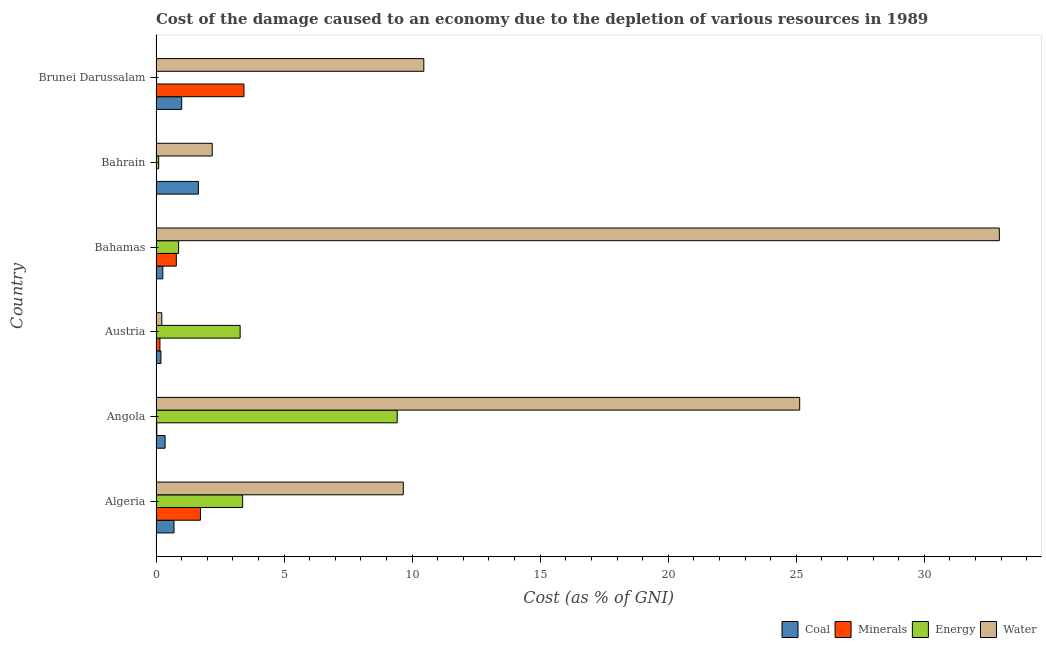How many different coloured bars are there?
Make the answer very short. 4. Are the number of bars on each tick of the Y-axis equal?
Offer a very short reply. Yes. How many bars are there on the 6th tick from the top?
Your response must be concise. 4. How many bars are there on the 6th tick from the bottom?
Your answer should be compact. 4. What is the label of the 2nd group of bars from the top?
Your answer should be compact. Bahrain. In how many cases, is the number of bars for a given country not equal to the number of legend labels?
Offer a terse response. 0. What is the cost of damage due to depletion of energy in Austria?
Provide a short and direct response. 3.28. Across all countries, what is the maximum cost of damage due to depletion of energy?
Make the answer very short. 9.42. Across all countries, what is the minimum cost of damage due to depletion of energy?
Your response must be concise. 0.02. In which country was the cost of damage due to depletion of minerals maximum?
Offer a very short reply. Brunei Darussalam. In which country was the cost of damage due to depletion of minerals minimum?
Your answer should be very brief. Bahrain. What is the total cost of damage due to depletion of water in the graph?
Provide a short and direct response. 80.59. What is the difference between the cost of damage due to depletion of water in Bahamas and that in Bahrain?
Make the answer very short. 30.73. What is the difference between the cost of damage due to depletion of minerals in Austria and the cost of damage due to depletion of energy in Bahrain?
Your answer should be compact. 0.05. What is the average cost of damage due to depletion of minerals per country?
Your response must be concise. 1.02. What is the ratio of the cost of damage due to depletion of coal in Angola to that in Austria?
Provide a short and direct response. 1.85. What is the difference between the highest and the second highest cost of damage due to depletion of coal?
Offer a terse response. 0.65. What is the difference between the highest and the lowest cost of damage due to depletion of energy?
Your answer should be very brief. 9.4. In how many countries, is the cost of damage due to depletion of minerals greater than the average cost of damage due to depletion of minerals taken over all countries?
Your answer should be very brief. 2. Is it the case that in every country, the sum of the cost of damage due to depletion of water and cost of damage due to depletion of coal is greater than the sum of cost of damage due to depletion of minerals and cost of damage due to depletion of energy?
Your answer should be very brief. No. What does the 1st bar from the top in Bahamas represents?
Provide a short and direct response. Water. What does the 1st bar from the bottom in Algeria represents?
Your answer should be very brief. Coal. Are all the bars in the graph horizontal?
Keep it short and to the point. Yes. How many countries are there in the graph?
Offer a terse response. 6. Are the values on the major ticks of X-axis written in scientific E-notation?
Make the answer very short. No. Does the graph contain any zero values?
Offer a terse response. No. Where does the legend appear in the graph?
Offer a terse response. Bottom right. What is the title of the graph?
Offer a very short reply. Cost of the damage caused to an economy due to the depletion of various resources in 1989 . What is the label or title of the X-axis?
Provide a succinct answer. Cost (as % of GNI). What is the label or title of the Y-axis?
Make the answer very short. Country. What is the Cost (as % of GNI) in Coal in Algeria?
Ensure brevity in your answer.  0.7. What is the Cost (as % of GNI) in Minerals in Algeria?
Make the answer very short. 1.73. What is the Cost (as % of GNI) in Energy in Algeria?
Give a very brief answer. 3.38. What is the Cost (as % of GNI) of Water in Algeria?
Provide a succinct answer. 9.66. What is the Cost (as % of GNI) in Coal in Angola?
Provide a succinct answer. 0.35. What is the Cost (as % of GNI) in Minerals in Angola?
Provide a short and direct response. 0.03. What is the Cost (as % of GNI) of Energy in Angola?
Keep it short and to the point. 9.42. What is the Cost (as % of GNI) of Water in Angola?
Offer a very short reply. 25.13. What is the Cost (as % of GNI) in Coal in Austria?
Offer a terse response. 0.19. What is the Cost (as % of GNI) in Minerals in Austria?
Ensure brevity in your answer.  0.15. What is the Cost (as % of GNI) in Energy in Austria?
Your response must be concise. 3.28. What is the Cost (as % of GNI) in Water in Austria?
Offer a very short reply. 0.23. What is the Cost (as % of GNI) in Coal in Bahamas?
Your response must be concise. 0.27. What is the Cost (as % of GNI) in Minerals in Bahamas?
Your response must be concise. 0.79. What is the Cost (as % of GNI) in Energy in Bahamas?
Your answer should be very brief. 0.88. What is the Cost (as % of GNI) in Water in Bahamas?
Provide a succinct answer. 32.93. What is the Cost (as % of GNI) of Coal in Bahrain?
Your answer should be compact. 1.66. What is the Cost (as % of GNI) in Minerals in Bahrain?
Provide a succinct answer. 0.01. What is the Cost (as % of GNI) in Energy in Bahrain?
Give a very brief answer. 0.1. What is the Cost (as % of GNI) in Water in Bahrain?
Keep it short and to the point. 2.19. What is the Cost (as % of GNI) in Coal in Brunei Darussalam?
Your response must be concise. 1. What is the Cost (as % of GNI) in Minerals in Brunei Darussalam?
Ensure brevity in your answer.  3.43. What is the Cost (as % of GNI) in Energy in Brunei Darussalam?
Give a very brief answer. 0.02. What is the Cost (as % of GNI) of Water in Brunei Darussalam?
Keep it short and to the point. 10.46. Across all countries, what is the maximum Cost (as % of GNI) in Coal?
Offer a terse response. 1.66. Across all countries, what is the maximum Cost (as % of GNI) in Minerals?
Offer a terse response. 3.43. Across all countries, what is the maximum Cost (as % of GNI) in Energy?
Provide a short and direct response. 9.42. Across all countries, what is the maximum Cost (as % of GNI) of Water?
Your answer should be very brief. 32.93. Across all countries, what is the minimum Cost (as % of GNI) in Coal?
Your answer should be very brief. 0.19. Across all countries, what is the minimum Cost (as % of GNI) in Minerals?
Provide a short and direct response. 0.01. Across all countries, what is the minimum Cost (as % of GNI) of Energy?
Keep it short and to the point. 0.02. Across all countries, what is the minimum Cost (as % of GNI) of Water?
Make the answer very short. 0.23. What is the total Cost (as % of GNI) in Coal in the graph?
Ensure brevity in your answer.  4.17. What is the total Cost (as % of GNI) in Minerals in the graph?
Make the answer very short. 6.15. What is the total Cost (as % of GNI) of Energy in the graph?
Your answer should be compact. 17.09. What is the total Cost (as % of GNI) in Water in the graph?
Offer a terse response. 80.59. What is the difference between the Cost (as % of GNI) of Coal in Algeria and that in Angola?
Provide a succinct answer. 0.35. What is the difference between the Cost (as % of GNI) of Minerals in Algeria and that in Angola?
Offer a terse response. 1.7. What is the difference between the Cost (as % of GNI) in Energy in Algeria and that in Angola?
Provide a short and direct response. -6.04. What is the difference between the Cost (as % of GNI) of Water in Algeria and that in Angola?
Offer a terse response. -15.48. What is the difference between the Cost (as % of GNI) of Coal in Algeria and that in Austria?
Your response must be concise. 0.51. What is the difference between the Cost (as % of GNI) in Minerals in Algeria and that in Austria?
Your answer should be compact. 1.58. What is the difference between the Cost (as % of GNI) of Energy in Algeria and that in Austria?
Your answer should be very brief. 0.1. What is the difference between the Cost (as % of GNI) of Water in Algeria and that in Austria?
Ensure brevity in your answer.  9.43. What is the difference between the Cost (as % of GNI) of Coal in Algeria and that in Bahamas?
Your answer should be compact. 0.44. What is the difference between the Cost (as % of GNI) in Minerals in Algeria and that in Bahamas?
Give a very brief answer. 0.94. What is the difference between the Cost (as % of GNI) of Energy in Algeria and that in Bahamas?
Keep it short and to the point. 2.5. What is the difference between the Cost (as % of GNI) of Water in Algeria and that in Bahamas?
Give a very brief answer. -23.27. What is the difference between the Cost (as % of GNI) of Coal in Algeria and that in Bahrain?
Provide a succinct answer. -0.95. What is the difference between the Cost (as % of GNI) of Minerals in Algeria and that in Bahrain?
Offer a terse response. 1.73. What is the difference between the Cost (as % of GNI) in Energy in Algeria and that in Bahrain?
Offer a very short reply. 3.28. What is the difference between the Cost (as % of GNI) in Water in Algeria and that in Bahrain?
Ensure brevity in your answer.  7.46. What is the difference between the Cost (as % of GNI) in Coal in Algeria and that in Brunei Darussalam?
Your answer should be compact. -0.3. What is the difference between the Cost (as % of GNI) in Minerals in Algeria and that in Brunei Darussalam?
Ensure brevity in your answer.  -1.7. What is the difference between the Cost (as % of GNI) in Energy in Algeria and that in Brunei Darussalam?
Give a very brief answer. 3.36. What is the difference between the Cost (as % of GNI) of Water in Algeria and that in Brunei Darussalam?
Keep it short and to the point. -0.8. What is the difference between the Cost (as % of GNI) in Coal in Angola and that in Austria?
Offer a terse response. 0.16. What is the difference between the Cost (as % of GNI) in Minerals in Angola and that in Austria?
Provide a succinct answer. -0.12. What is the difference between the Cost (as % of GNI) in Energy in Angola and that in Austria?
Your response must be concise. 6.13. What is the difference between the Cost (as % of GNI) in Water in Angola and that in Austria?
Offer a terse response. 24.91. What is the difference between the Cost (as % of GNI) of Coal in Angola and that in Bahamas?
Provide a succinct answer. 0.09. What is the difference between the Cost (as % of GNI) of Minerals in Angola and that in Bahamas?
Your answer should be compact. -0.76. What is the difference between the Cost (as % of GNI) in Energy in Angola and that in Bahamas?
Provide a short and direct response. 8.54. What is the difference between the Cost (as % of GNI) in Water in Angola and that in Bahamas?
Provide a short and direct response. -7.8. What is the difference between the Cost (as % of GNI) in Coal in Angola and that in Bahrain?
Your answer should be compact. -1.3. What is the difference between the Cost (as % of GNI) of Minerals in Angola and that in Bahrain?
Your answer should be very brief. 0.02. What is the difference between the Cost (as % of GNI) of Energy in Angola and that in Bahrain?
Ensure brevity in your answer.  9.31. What is the difference between the Cost (as % of GNI) of Water in Angola and that in Bahrain?
Offer a terse response. 22.94. What is the difference between the Cost (as % of GNI) in Coal in Angola and that in Brunei Darussalam?
Make the answer very short. -0.65. What is the difference between the Cost (as % of GNI) in Minerals in Angola and that in Brunei Darussalam?
Offer a terse response. -3.4. What is the difference between the Cost (as % of GNI) in Energy in Angola and that in Brunei Darussalam?
Ensure brevity in your answer.  9.4. What is the difference between the Cost (as % of GNI) of Water in Angola and that in Brunei Darussalam?
Your answer should be compact. 14.68. What is the difference between the Cost (as % of GNI) in Coal in Austria and that in Bahamas?
Offer a terse response. -0.07. What is the difference between the Cost (as % of GNI) in Minerals in Austria and that in Bahamas?
Your answer should be compact. -0.64. What is the difference between the Cost (as % of GNI) in Energy in Austria and that in Bahamas?
Your answer should be very brief. 2.4. What is the difference between the Cost (as % of GNI) in Water in Austria and that in Bahamas?
Provide a succinct answer. -32.7. What is the difference between the Cost (as % of GNI) of Coal in Austria and that in Bahrain?
Provide a short and direct response. -1.46. What is the difference between the Cost (as % of GNI) in Minerals in Austria and that in Bahrain?
Ensure brevity in your answer.  0.15. What is the difference between the Cost (as % of GNI) in Energy in Austria and that in Bahrain?
Offer a terse response. 3.18. What is the difference between the Cost (as % of GNI) of Water in Austria and that in Bahrain?
Give a very brief answer. -1.97. What is the difference between the Cost (as % of GNI) in Coal in Austria and that in Brunei Darussalam?
Provide a short and direct response. -0.81. What is the difference between the Cost (as % of GNI) in Minerals in Austria and that in Brunei Darussalam?
Ensure brevity in your answer.  -3.28. What is the difference between the Cost (as % of GNI) of Energy in Austria and that in Brunei Darussalam?
Your answer should be very brief. 3.26. What is the difference between the Cost (as % of GNI) of Water in Austria and that in Brunei Darussalam?
Provide a short and direct response. -10.23. What is the difference between the Cost (as % of GNI) in Coal in Bahamas and that in Bahrain?
Make the answer very short. -1.39. What is the difference between the Cost (as % of GNI) in Minerals in Bahamas and that in Bahrain?
Provide a succinct answer. 0.79. What is the difference between the Cost (as % of GNI) of Energy in Bahamas and that in Bahrain?
Ensure brevity in your answer.  0.78. What is the difference between the Cost (as % of GNI) of Water in Bahamas and that in Bahrain?
Give a very brief answer. 30.73. What is the difference between the Cost (as % of GNI) in Coal in Bahamas and that in Brunei Darussalam?
Provide a short and direct response. -0.74. What is the difference between the Cost (as % of GNI) of Minerals in Bahamas and that in Brunei Darussalam?
Give a very brief answer. -2.64. What is the difference between the Cost (as % of GNI) of Energy in Bahamas and that in Brunei Darussalam?
Your answer should be very brief. 0.86. What is the difference between the Cost (as % of GNI) in Water in Bahamas and that in Brunei Darussalam?
Offer a terse response. 22.47. What is the difference between the Cost (as % of GNI) in Coal in Bahrain and that in Brunei Darussalam?
Make the answer very short. 0.65. What is the difference between the Cost (as % of GNI) in Minerals in Bahrain and that in Brunei Darussalam?
Offer a very short reply. -3.43. What is the difference between the Cost (as % of GNI) in Energy in Bahrain and that in Brunei Darussalam?
Give a very brief answer. 0.08. What is the difference between the Cost (as % of GNI) of Water in Bahrain and that in Brunei Darussalam?
Make the answer very short. -8.26. What is the difference between the Cost (as % of GNI) of Coal in Algeria and the Cost (as % of GNI) of Minerals in Angola?
Provide a short and direct response. 0.67. What is the difference between the Cost (as % of GNI) in Coal in Algeria and the Cost (as % of GNI) in Energy in Angola?
Provide a short and direct response. -8.72. What is the difference between the Cost (as % of GNI) in Coal in Algeria and the Cost (as % of GNI) in Water in Angola?
Keep it short and to the point. -24.43. What is the difference between the Cost (as % of GNI) in Minerals in Algeria and the Cost (as % of GNI) in Energy in Angola?
Offer a very short reply. -7.68. What is the difference between the Cost (as % of GNI) in Minerals in Algeria and the Cost (as % of GNI) in Water in Angola?
Your answer should be very brief. -23.4. What is the difference between the Cost (as % of GNI) of Energy in Algeria and the Cost (as % of GNI) of Water in Angola?
Your answer should be compact. -21.75. What is the difference between the Cost (as % of GNI) of Coal in Algeria and the Cost (as % of GNI) of Minerals in Austria?
Provide a short and direct response. 0.55. What is the difference between the Cost (as % of GNI) of Coal in Algeria and the Cost (as % of GNI) of Energy in Austria?
Your answer should be very brief. -2.58. What is the difference between the Cost (as % of GNI) in Coal in Algeria and the Cost (as % of GNI) in Water in Austria?
Your answer should be very brief. 0.48. What is the difference between the Cost (as % of GNI) of Minerals in Algeria and the Cost (as % of GNI) of Energy in Austria?
Keep it short and to the point. -1.55. What is the difference between the Cost (as % of GNI) in Minerals in Algeria and the Cost (as % of GNI) in Water in Austria?
Offer a terse response. 1.51. What is the difference between the Cost (as % of GNI) of Energy in Algeria and the Cost (as % of GNI) of Water in Austria?
Keep it short and to the point. 3.16. What is the difference between the Cost (as % of GNI) in Coal in Algeria and the Cost (as % of GNI) in Minerals in Bahamas?
Provide a succinct answer. -0.09. What is the difference between the Cost (as % of GNI) in Coal in Algeria and the Cost (as % of GNI) in Energy in Bahamas?
Make the answer very short. -0.18. What is the difference between the Cost (as % of GNI) of Coal in Algeria and the Cost (as % of GNI) of Water in Bahamas?
Offer a very short reply. -32.23. What is the difference between the Cost (as % of GNI) of Minerals in Algeria and the Cost (as % of GNI) of Energy in Bahamas?
Your answer should be very brief. 0.85. What is the difference between the Cost (as % of GNI) in Minerals in Algeria and the Cost (as % of GNI) in Water in Bahamas?
Your answer should be compact. -31.19. What is the difference between the Cost (as % of GNI) of Energy in Algeria and the Cost (as % of GNI) of Water in Bahamas?
Offer a terse response. -29.55. What is the difference between the Cost (as % of GNI) of Coal in Algeria and the Cost (as % of GNI) of Minerals in Bahrain?
Provide a short and direct response. 0.69. What is the difference between the Cost (as % of GNI) of Coal in Algeria and the Cost (as % of GNI) of Energy in Bahrain?
Provide a succinct answer. 0.6. What is the difference between the Cost (as % of GNI) of Coal in Algeria and the Cost (as % of GNI) of Water in Bahrain?
Give a very brief answer. -1.49. What is the difference between the Cost (as % of GNI) in Minerals in Algeria and the Cost (as % of GNI) in Energy in Bahrain?
Your answer should be very brief. 1.63. What is the difference between the Cost (as % of GNI) in Minerals in Algeria and the Cost (as % of GNI) in Water in Bahrain?
Provide a short and direct response. -0.46. What is the difference between the Cost (as % of GNI) of Energy in Algeria and the Cost (as % of GNI) of Water in Bahrain?
Keep it short and to the point. 1.19. What is the difference between the Cost (as % of GNI) in Coal in Algeria and the Cost (as % of GNI) in Minerals in Brunei Darussalam?
Give a very brief answer. -2.73. What is the difference between the Cost (as % of GNI) in Coal in Algeria and the Cost (as % of GNI) in Energy in Brunei Darussalam?
Provide a short and direct response. 0.68. What is the difference between the Cost (as % of GNI) in Coal in Algeria and the Cost (as % of GNI) in Water in Brunei Darussalam?
Keep it short and to the point. -9.75. What is the difference between the Cost (as % of GNI) in Minerals in Algeria and the Cost (as % of GNI) in Energy in Brunei Darussalam?
Make the answer very short. 1.71. What is the difference between the Cost (as % of GNI) of Minerals in Algeria and the Cost (as % of GNI) of Water in Brunei Darussalam?
Provide a short and direct response. -8.72. What is the difference between the Cost (as % of GNI) in Energy in Algeria and the Cost (as % of GNI) in Water in Brunei Darussalam?
Ensure brevity in your answer.  -7.07. What is the difference between the Cost (as % of GNI) in Coal in Angola and the Cost (as % of GNI) in Minerals in Austria?
Make the answer very short. 0.2. What is the difference between the Cost (as % of GNI) of Coal in Angola and the Cost (as % of GNI) of Energy in Austria?
Offer a very short reply. -2.93. What is the difference between the Cost (as % of GNI) of Coal in Angola and the Cost (as % of GNI) of Water in Austria?
Your answer should be compact. 0.13. What is the difference between the Cost (as % of GNI) in Minerals in Angola and the Cost (as % of GNI) in Energy in Austria?
Ensure brevity in your answer.  -3.25. What is the difference between the Cost (as % of GNI) of Minerals in Angola and the Cost (as % of GNI) of Water in Austria?
Your response must be concise. -0.2. What is the difference between the Cost (as % of GNI) in Energy in Angola and the Cost (as % of GNI) in Water in Austria?
Keep it short and to the point. 9.19. What is the difference between the Cost (as % of GNI) in Coal in Angola and the Cost (as % of GNI) in Minerals in Bahamas?
Make the answer very short. -0.44. What is the difference between the Cost (as % of GNI) of Coal in Angola and the Cost (as % of GNI) of Energy in Bahamas?
Offer a very short reply. -0.53. What is the difference between the Cost (as % of GNI) of Coal in Angola and the Cost (as % of GNI) of Water in Bahamas?
Your response must be concise. -32.57. What is the difference between the Cost (as % of GNI) of Minerals in Angola and the Cost (as % of GNI) of Energy in Bahamas?
Provide a short and direct response. -0.85. What is the difference between the Cost (as % of GNI) in Minerals in Angola and the Cost (as % of GNI) in Water in Bahamas?
Your answer should be compact. -32.9. What is the difference between the Cost (as % of GNI) of Energy in Angola and the Cost (as % of GNI) of Water in Bahamas?
Provide a succinct answer. -23.51. What is the difference between the Cost (as % of GNI) in Coal in Angola and the Cost (as % of GNI) in Minerals in Bahrain?
Offer a terse response. 0.35. What is the difference between the Cost (as % of GNI) in Coal in Angola and the Cost (as % of GNI) in Energy in Bahrain?
Provide a short and direct response. 0.25. What is the difference between the Cost (as % of GNI) in Coal in Angola and the Cost (as % of GNI) in Water in Bahrain?
Make the answer very short. -1.84. What is the difference between the Cost (as % of GNI) of Minerals in Angola and the Cost (as % of GNI) of Energy in Bahrain?
Provide a succinct answer. -0.07. What is the difference between the Cost (as % of GNI) of Minerals in Angola and the Cost (as % of GNI) of Water in Bahrain?
Give a very brief answer. -2.16. What is the difference between the Cost (as % of GNI) of Energy in Angola and the Cost (as % of GNI) of Water in Bahrain?
Keep it short and to the point. 7.22. What is the difference between the Cost (as % of GNI) in Coal in Angola and the Cost (as % of GNI) in Minerals in Brunei Darussalam?
Provide a succinct answer. -3.08. What is the difference between the Cost (as % of GNI) in Coal in Angola and the Cost (as % of GNI) in Energy in Brunei Darussalam?
Offer a terse response. 0.33. What is the difference between the Cost (as % of GNI) of Coal in Angola and the Cost (as % of GNI) of Water in Brunei Darussalam?
Your answer should be compact. -10.1. What is the difference between the Cost (as % of GNI) of Minerals in Angola and the Cost (as % of GNI) of Energy in Brunei Darussalam?
Make the answer very short. 0.01. What is the difference between the Cost (as % of GNI) of Minerals in Angola and the Cost (as % of GNI) of Water in Brunei Darussalam?
Your answer should be very brief. -10.43. What is the difference between the Cost (as % of GNI) of Energy in Angola and the Cost (as % of GNI) of Water in Brunei Darussalam?
Your answer should be compact. -1.04. What is the difference between the Cost (as % of GNI) of Coal in Austria and the Cost (as % of GNI) of Minerals in Bahamas?
Your response must be concise. -0.6. What is the difference between the Cost (as % of GNI) of Coal in Austria and the Cost (as % of GNI) of Energy in Bahamas?
Offer a very short reply. -0.69. What is the difference between the Cost (as % of GNI) in Coal in Austria and the Cost (as % of GNI) in Water in Bahamas?
Provide a succinct answer. -32.74. What is the difference between the Cost (as % of GNI) of Minerals in Austria and the Cost (as % of GNI) of Energy in Bahamas?
Ensure brevity in your answer.  -0.73. What is the difference between the Cost (as % of GNI) of Minerals in Austria and the Cost (as % of GNI) of Water in Bahamas?
Offer a terse response. -32.77. What is the difference between the Cost (as % of GNI) in Energy in Austria and the Cost (as % of GNI) in Water in Bahamas?
Your answer should be very brief. -29.64. What is the difference between the Cost (as % of GNI) in Coal in Austria and the Cost (as % of GNI) in Minerals in Bahrain?
Provide a short and direct response. 0.18. What is the difference between the Cost (as % of GNI) in Coal in Austria and the Cost (as % of GNI) in Energy in Bahrain?
Your answer should be compact. 0.09. What is the difference between the Cost (as % of GNI) of Coal in Austria and the Cost (as % of GNI) of Water in Bahrain?
Offer a very short reply. -2. What is the difference between the Cost (as % of GNI) in Minerals in Austria and the Cost (as % of GNI) in Energy in Bahrain?
Offer a terse response. 0.05. What is the difference between the Cost (as % of GNI) in Minerals in Austria and the Cost (as % of GNI) in Water in Bahrain?
Make the answer very short. -2.04. What is the difference between the Cost (as % of GNI) of Energy in Austria and the Cost (as % of GNI) of Water in Bahrain?
Your answer should be very brief. 1.09. What is the difference between the Cost (as % of GNI) in Coal in Austria and the Cost (as % of GNI) in Minerals in Brunei Darussalam?
Your response must be concise. -3.24. What is the difference between the Cost (as % of GNI) of Coal in Austria and the Cost (as % of GNI) of Energy in Brunei Darussalam?
Your answer should be compact. 0.17. What is the difference between the Cost (as % of GNI) in Coal in Austria and the Cost (as % of GNI) in Water in Brunei Darussalam?
Give a very brief answer. -10.27. What is the difference between the Cost (as % of GNI) in Minerals in Austria and the Cost (as % of GNI) in Energy in Brunei Darussalam?
Offer a terse response. 0.13. What is the difference between the Cost (as % of GNI) in Minerals in Austria and the Cost (as % of GNI) in Water in Brunei Darussalam?
Your answer should be compact. -10.3. What is the difference between the Cost (as % of GNI) of Energy in Austria and the Cost (as % of GNI) of Water in Brunei Darussalam?
Provide a short and direct response. -7.17. What is the difference between the Cost (as % of GNI) in Coal in Bahamas and the Cost (as % of GNI) in Minerals in Bahrain?
Ensure brevity in your answer.  0.26. What is the difference between the Cost (as % of GNI) of Coal in Bahamas and the Cost (as % of GNI) of Energy in Bahrain?
Your answer should be very brief. 0.16. What is the difference between the Cost (as % of GNI) in Coal in Bahamas and the Cost (as % of GNI) in Water in Bahrain?
Make the answer very short. -1.93. What is the difference between the Cost (as % of GNI) of Minerals in Bahamas and the Cost (as % of GNI) of Energy in Bahrain?
Your answer should be very brief. 0.69. What is the difference between the Cost (as % of GNI) of Minerals in Bahamas and the Cost (as % of GNI) of Water in Bahrain?
Give a very brief answer. -1.4. What is the difference between the Cost (as % of GNI) in Energy in Bahamas and the Cost (as % of GNI) in Water in Bahrain?
Make the answer very short. -1.31. What is the difference between the Cost (as % of GNI) in Coal in Bahamas and the Cost (as % of GNI) in Minerals in Brunei Darussalam?
Give a very brief answer. -3.17. What is the difference between the Cost (as % of GNI) of Coal in Bahamas and the Cost (as % of GNI) of Energy in Brunei Darussalam?
Make the answer very short. 0.24. What is the difference between the Cost (as % of GNI) of Coal in Bahamas and the Cost (as % of GNI) of Water in Brunei Darussalam?
Provide a short and direct response. -10.19. What is the difference between the Cost (as % of GNI) of Minerals in Bahamas and the Cost (as % of GNI) of Energy in Brunei Darussalam?
Ensure brevity in your answer.  0.77. What is the difference between the Cost (as % of GNI) in Minerals in Bahamas and the Cost (as % of GNI) in Water in Brunei Darussalam?
Provide a succinct answer. -9.66. What is the difference between the Cost (as % of GNI) of Energy in Bahamas and the Cost (as % of GNI) of Water in Brunei Darussalam?
Keep it short and to the point. -9.58. What is the difference between the Cost (as % of GNI) of Coal in Bahrain and the Cost (as % of GNI) of Minerals in Brunei Darussalam?
Your answer should be compact. -1.78. What is the difference between the Cost (as % of GNI) in Coal in Bahrain and the Cost (as % of GNI) in Energy in Brunei Darussalam?
Make the answer very short. 1.63. What is the difference between the Cost (as % of GNI) of Coal in Bahrain and the Cost (as % of GNI) of Water in Brunei Darussalam?
Give a very brief answer. -8.8. What is the difference between the Cost (as % of GNI) in Minerals in Bahrain and the Cost (as % of GNI) in Energy in Brunei Darussalam?
Your answer should be compact. -0.01. What is the difference between the Cost (as % of GNI) in Minerals in Bahrain and the Cost (as % of GNI) in Water in Brunei Darussalam?
Make the answer very short. -10.45. What is the difference between the Cost (as % of GNI) in Energy in Bahrain and the Cost (as % of GNI) in Water in Brunei Darussalam?
Make the answer very short. -10.35. What is the average Cost (as % of GNI) in Coal per country?
Your answer should be compact. 0.69. What is the average Cost (as % of GNI) of Energy per country?
Keep it short and to the point. 2.85. What is the average Cost (as % of GNI) of Water per country?
Give a very brief answer. 13.43. What is the difference between the Cost (as % of GNI) of Coal and Cost (as % of GNI) of Minerals in Algeria?
Give a very brief answer. -1.03. What is the difference between the Cost (as % of GNI) in Coal and Cost (as % of GNI) in Energy in Algeria?
Offer a terse response. -2.68. What is the difference between the Cost (as % of GNI) of Coal and Cost (as % of GNI) of Water in Algeria?
Offer a very short reply. -8.95. What is the difference between the Cost (as % of GNI) of Minerals and Cost (as % of GNI) of Energy in Algeria?
Your answer should be compact. -1.65. What is the difference between the Cost (as % of GNI) in Minerals and Cost (as % of GNI) in Water in Algeria?
Offer a terse response. -7.92. What is the difference between the Cost (as % of GNI) in Energy and Cost (as % of GNI) in Water in Algeria?
Make the answer very short. -6.27. What is the difference between the Cost (as % of GNI) of Coal and Cost (as % of GNI) of Minerals in Angola?
Make the answer very short. 0.32. What is the difference between the Cost (as % of GNI) of Coal and Cost (as % of GNI) of Energy in Angola?
Offer a terse response. -9.06. What is the difference between the Cost (as % of GNI) of Coal and Cost (as % of GNI) of Water in Angola?
Provide a succinct answer. -24.78. What is the difference between the Cost (as % of GNI) in Minerals and Cost (as % of GNI) in Energy in Angola?
Your answer should be very brief. -9.39. What is the difference between the Cost (as % of GNI) of Minerals and Cost (as % of GNI) of Water in Angola?
Give a very brief answer. -25.1. What is the difference between the Cost (as % of GNI) of Energy and Cost (as % of GNI) of Water in Angola?
Provide a succinct answer. -15.72. What is the difference between the Cost (as % of GNI) of Coal and Cost (as % of GNI) of Minerals in Austria?
Ensure brevity in your answer.  0.04. What is the difference between the Cost (as % of GNI) in Coal and Cost (as % of GNI) in Energy in Austria?
Give a very brief answer. -3.09. What is the difference between the Cost (as % of GNI) in Coal and Cost (as % of GNI) in Water in Austria?
Provide a succinct answer. -0.03. What is the difference between the Cost (as % of GNI) of Minerals and Cost (as % of GNI) of Energy in Austria?
Give a very brief answer. -3.13. What is the difference between the Cost (as % of GNI) in Minerals and Cost (as % of GNI) in Water in Austria?
Give a very brief answer. -0.07. What is the difference between the Cost (as % of GNI) in Energy and Cost (as % of GNI) in Water in Austria?
Ensure brevity in your answer.  3.06. What is the difference between the Cost (as % of GNI) in Coal and Cost (as % of GNI) in Minerals in Bahamas?
Your answer should be very brief. -0.53. What is the difference between the Cost (as % of GNI) in Coal and Cost (as % of GNI) in Energy in Bahamas?
Your response must be concise. -0.62. What is the difference between the Cost (as % of GNI) in Coal and Cost (as % of GNI) in Water in Bahamas?
Your answer should be very brief. -32.66. What is the difference between the Cost (as % of GNI) of Minerals and Cost (as % of GNI) of Energy in Bahamas?
Provide a short and direct response. -0.09. What is the difference between the Cost (as % of GNI) of Minerals and Cost (as % of GNI) of Water in Bahamas?
Offer a terse response. -32.14. What is the difference between the Cost (as % of GNI) of Energy and Cost (as % of GNI) of Water in Bahamas?
Offer a terse response. -32.05. What is the difference between the Cost (as % of GNI) of Coal and Cost (as % of GNI) of Minerals in Bahrain?
Your response must be concise. 1.65. What is the difference between the Cost (as % of GNI) of Coal and Cost (as % of GNI) of Energy in Bahrain?
Your answer should be very brief. 1.55. What is the difference between the Cost (as % of GNI) of Coal and Cost (as % of GNI) of Water in Bahrain?
Give a very brief answer. -0.54. What is the difference between the Cost (as % of GNI) of Minerals and Cost (as % of GNI) of Energy in Bahrain?
Give a very brief answer. -0.1. What is the difference between the Cost (as % of GNI) in Minerals and Cost (as % of GNI) in Water in Bahrain?
Your answer should be compact. -2.19. What is the difference between the Cost (as % of GNI) in Energy and Cost (as % of GNI) in Water in Bahrain?
Make the answer very short. -2.09. What is the difference between the Cost (as % of GNI) of Coal and Cost (as % of GNI) of Minerals in Brunei Darussalam?
Ensure brevity in your answer.  -2.43. What is the difference between the Cost (as % of GNI) in Coal and Cost (as % of GNI) in Energy in Brunei Darussalam?
Give a very brief answer. 0.98. What is the difference between the Cost (as % of GNI) in Coal and Cost (as % of GNI) in Water in Brunei Darussalam?
Provide a succinct answer. -9.46. What is the difference between the Cost (as % of GNI) in Minerals and Cost (as % of GNI) in Energy in Brunei Darussalam?
Provide a short and direct response. 3.41. What is the difference between the Cost (as % of GNI) of Minerals and Cost (as % of GNI) of Water in Brunei Darussalam?
Provide a short and direct response. -7.02. What is the difference between the Cost (as % of GNI) of Energy and Cost (as % of GNI) of Water in Brunei Darussalam?
Make the answer very short. -10.44. What is the ratio of the Cost (as % of GNI) of Coal in Algeria to that in Angola?
Keep it short and to the point. 1.98. What is the ratio of the Cost (as % of GNI) in Minerals in Algeria to that in Angola?
Your answer should be very brief. 57.49. What is the ratio of the Cost (as % of GNI) in Energy in Algeria to that in Angola?
Make the answer very short. 0.36. What is the ratio of the Cost (as % of GNI) in Water in Algeria to that in Angola?
Your answer should be very brief. 0.38. What is the ratio of the Cost (as % of GNI) in Coal in Algeria to that in Austria?
Give a very brief answer. 3.66. What is the ratio of the Cost (as % of GNI) of Minerals in Algeria to that in Austria?
Your answer should be compact. 11.35. What is the ratio of the Cost (as % of GNI) of Energy in Algeria to that in Austria?
Ensure brevity in your answer.  1.03. What is the ratio of the Cost (as % of GNI) of Water in Algeria to that in Austria?
Provide a succinct answer. 42.71. What is the ratio of the Cost (as % of GNI) of Coal in Algeria to that in Bahamas?
Your answer should be compact. 2.64. What is the ratio of the Cost (as % of GNI) in Minerals in Algeria to that in Bahamas?
Your answer should be compact. 2.19. What is the ratio of the Cost (as % of GNI) of Energy in Algeria to that in Bahamas?
Provide a succinct answer. 3.84. What is the ratio of the Cost (as % of GNI) of Water in Algeria to that in Bahamas?
Provide a succinct answer. 0.29. What is the ratio of the Cost (as % of GNI) of Coal in Algeria to that in Bahrain?
Make the answer very short. 0.42. What is the ratio of the Cost (as % of GNI) of Minerals in Algeria to that in Bahrain?
Your answer should be very brief. 254.98. What is the ratio of the Cost (as % of GNI) of Energy in Algeria to that in Bahrain?
Provide a short and direct response. 32.44. What is the ratio of the Cost (as % of GNI) in Water in Algeria to that in Bahrain?
Provide a succinct answer. 4.4. What is the ratio of the Cost (as % of GNI) of Coal in Algeria to that in Brunei Darussalam?
Your answer should be very brief. 0.7. What is the ratio of the Cost (as % of GNI) in Minerals in Algeria to that in Brunei Darussalam?
Your answer should be very brief. 0.51. What is the ratio of the Cost (as % of GNI) in Energy in Algeria to that in Brunei Darussalam?
Your answer should be very brief. 159.2. What is the ratio of the Cost (as % of GNI) of Water in Algeria to that in Brunei Darussalam?
Make the answer very short. 0.92. What is the ratio of the Cost (as % of GNI) in Coal in Angola to that in Austria?
Keep it short and to the point. 1.85. What is the ratio of the Cost (as % of GNI) in Minerals in Angola to that in Austria?
Offer a very short reply. 0.2. What is the ratio of the Cost (as % of GNI) in Energy in Angola to that in Austria?
Your response must be concise. 2.87. What is the ratio of the Cost (as % of GNI) in Water in Angola to that in Austria?
Make the answer very short. 111.17. What is the ratio of the Cost (as % of GNI) of Coal in Angola to that in Bahamas?
Provide a short and direct response. 1.33. What is the ratio of the Cost (as % of GNI) in Minerals in Angola to that in Bahamas?
Provide a succinct answer. 0.04. What is the ratio of the Cost (as % of GNI) of Energy in Angola to that in Bahamas?
Provide a succinct answer. 10.68. What is the ratio of the Cost (as % of GNI) in Water in Angola to that in Bahamas?
Your answer should be compact. 0.76. What is the ratio of the Cost (as % of GNI) of Coal in Angola to that in Bahrain?
Offer a terse response. 0.21. What is the ratio of the Cost (as % of GNI) of Minerals in Angola to that in Bahrain?
Provide a short and direct response. 4.44. What is the ratio of the Cost (as % of GNI) in Energy in Angola to that in Bahrain?
Your response must be concise. 90.32. What is the ratio of the Cost (as % of GNI) of Water in Angola to that in Bahrain?
Provide a short and direct response. 11.45. What is the ratio of the Cost (as % of GNI) in Coal in Angola to that in Brunei Darussalam?
Your response must be concise. 0.35. What is the ratio of the Cost (as % of GNI) in Minerals in Angola to that in Brunei Darussalam?
Offer a terse response. 0.01. What is the ratio of the Cost (as % of GNI) of Energy in Angola to that in Brunei Darussalam?
Provide a short and direct response. 443.28. What is the ratio of the Cost (as % of GNI) in Water in Angola to that in Brunei Darussalam?
Make the answer very short. 2.4. What is the ratio of the Cost (as % of GNI) of Coal in Austria to that in Bahamas?
Provide a succinct answer. 0.72. What is the ratio of the Cost (as % of GNI) in Minerals in Austria to that in Bahamas?
Give a very brief answer. 0.19. What is the ratio of the Cost (as % of GNI) in Energy in Austria to that in Bahamas?
Offer a very short reply. 3.73. What is the ratio of the Cost (as % of GNI) of Water in Austria to that in Bahamas?
Provide a short and direct response. 0.01. What is the ratio of the Cost (as % of GNI) in Coal in Austria to that in Bahrain?
Offer a terse response. 0.12. What is the ratio of the Cost (as % of GNI) of Minerals in Austria to that in Bahrain?
Offer a very short reply. 22.47. What is the ratio of the Cost (as % of GNI) of Energy in Austria to that in Bahrain?
Make the answer very short. 31.5. What is the ratio of the Cost (as % of GNI) of Water in Austria to that in Bahrain?
Provide a succinct answer. 0.1. What is the ratio of the Cost (as % of GNI) in Coal in Austria to that in Brunei Darussalam?
Ensure brevity in your answer.  0.19. What is the ratio of the Cost (as % of GNI) of Minerals in Austria to that in Brunei Darussalam?
Your response must be concise. 0.04. What is the ratio of the Cost (as % of GNI) in Energy in Austria to that in Brunei Darussalam?
Your response must be concise. 154.62. What is the ratio of the Cost (as % of GNI) of Water in Austria to that in Brunei Darussalam?
Make the answer very short. 0.02. What is the ratio of the Cost (as % of GNI) in Coal in Bahamas to that in Bahrain?
Ensure brevity in your answer.  0.16. What is the ratio of the Cost (as % of GNI) of Minerals in Bahamas to that in Bahrain?
Offer a terse response. 116.42. What is the ratio of the Cost (as % of GNI) of Energy in Bahamas to that in Bahrain?
Make the answer very short. 8.45. What is the ratio of the Cost (as % of GNI) of Water in Bahamas to that in Bahrain?
Keep it short and to the point. 15. What is the ratio of the Cost (as % of GNI) of Coal in Bahamas to that in Brunei Darussalam?
Your answer should be very brief. 0.27. What is the ratio of the Cost (as % of GNI) in Minerals in Bahamas to that in Brunei Darussalam?
Provide a short and direct response. 0.23. What is the ratio of the Cost (as % of GNI) of Energy in Bahamas to that in Brunei Darussalam?
Provide a short and direct response. 41.49. What is the ratio of the Cost (as % of GNI) of Water in Bahamas to that in Brunei Darussalam?
Offer a terse response. 3.15. What is the ratio of the Cost (as % of GNI) in Coal in Bahrain to that in Brunei Darussalam?
Make the answer very short. 1.65. What is the ratio of the Cost (as % of GNI) of Minerals in Bahrain to that in Brunei Darussalam?
Give a very brief answer. 0. What is the ratio of the Cost (as % of GNI) of Energy in Bahrain to that in Brunei Darussalam?
Your response must be concise. 4.91. What is the ratio of the Cost (as % of GNI) in Water in Bahrain to that in Brunei Darussalam?
Provide a short and direct response. 0.21. What is the difference between the highest and the second highest Cost (as % of GNI) in Coal?
Provide a succinct answer. 0.65. What is the difference between the highest and the second highest Cost (as % of GNI) in Minerals?
Provide a succinct answer. 1.7. What is the difference between the highest and the second highest Cost (as % of GNI) of Energy?
Offer a terse response. 6.04. What is the difference between the highest and the second highest Cost (as % of GNI) of Water?
Provide a short and direct response. 7.8. What is the difference between the highest and the lowest Cost (as % of GNI) of Coal?
Your answer should be very brief. 1.46. What is the difference between the highest and the lowest Cost (as % of GNI) in Minerals?
Give a very brief answer. 3.43. What is the difference between the highest and the lowest Cost (as % of GNI) in Energy?
Keep it short and to the point. 9.4. What is the difference between the highest and the lowest Cost (as % of GNI) in Water?
Provide a succinct answer. 32.7. 